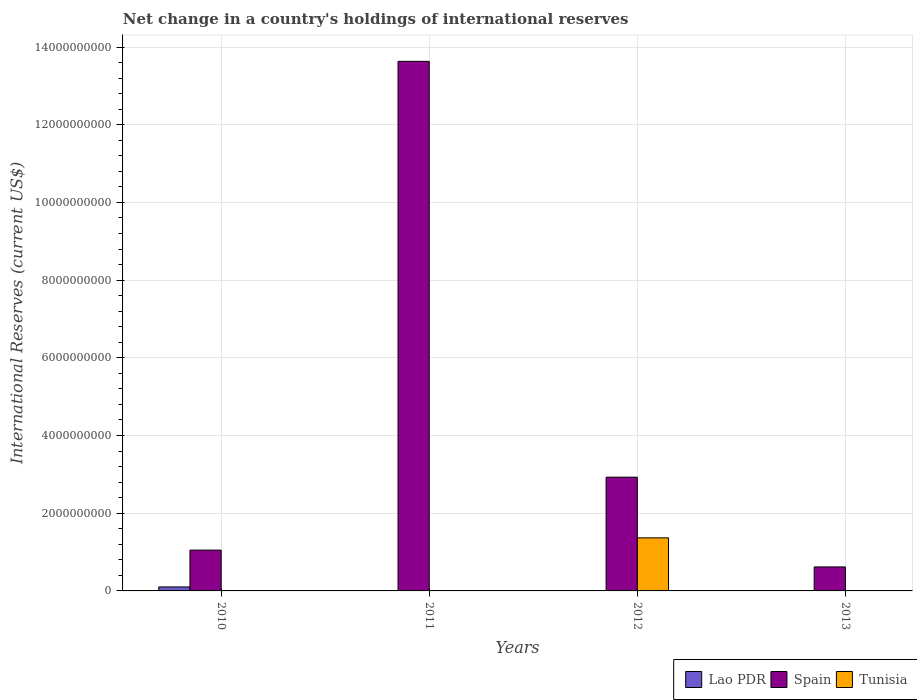How many different coloured bars are there?
Offer a terse response. 3. Are the number of bars per tick equal to the number of legend labels?
Your answer should be very brief. No. What is the label of the 3rd group of bars from the left?
Ensure brevity in your answer.  2012. What is the international reserves in Spain in 2012?
Your answer should be very brief. 2.93e+09. Across all years, what is the maximum international reserves in Lao PDR?
Offer a very short reply. 1.03e+08. Across all years, what is the minimum international reserves in Spain?
Provide a short and direct response. 6.17e+08. In which year was the international reserves in Spain maximum?
Make the answer very short. 2011. What is the total international reserves in Tunisia in the graph?
Your response must be concise. 1.37e+09. What is the difference between the international reserves in Spain in 2010 and that in 2013?
Ensure brevity in your answer.  4.33e+08. What is the difference between the international reserves in Tunisia in 2011 and the international reserves in Spain in 2013?
Give a very brief answer. -6.17e+08. What is the average international reserves in Tunisia per year?
Your answer should be very brief. 3.42e+08. In the year 2010, what is the difference between the international reserves in Spain and international reserves in Lao PDR?
Your answer should be compact. 9.48e+08. What is the ratio of the international reserves in Spain in 2010 to that in 2012?
Give a very brief answer. 0.36. What is the difference between the highest and the second highest international reserves in Spain?
Ensure brevity in your answer.  1.07e+1. What is the difference between the highest and the lowest international reserves in Tunisia?
Provide a short and direct response. 1.37e+09. In how many years, is the international reserves in Lao PDR greater than the average international reserves in Lao PDR taken over all years?
Give a very brief answer. 1. How many bars are there?
Give a very brief answer. 6. Are all the bars in the graph horizontal?
Offer a very short reply. No. How many years are there in the graph?
Keep it short and to the point. 4. What is the difference between two consecutive major ticks on the Y-axis?
Offer a terse response. 2.00e+09. Does the graph contain any zero values?
Your answer should be very brief. Yes. Does the graph contain grids?
Offer a terse response. Yes. Where does the legend appear in the graph?
Make the answer very short. Bottom right. How many legend labels are there?
Your answer should be very brief. 3. How are the legend labels stacked?
Provide a succinct answer. Horizontal. What is the title of the graph?
Offer a very short reply. Net change in a country's holdings of international reserves. What is the label or title of the Y-axis?
Make the answer very short. International Reserves (current US$). What is the International Reserves (current US$) of Lao PDR in 2010?
Ensure brevity in your answer.  1.03e+08. What is the International Reserves (current US$) of Spain in 2010?
Offer a very short reply. 1.05e+09. What is the International Reserves (current US$) of Tunisia in 2010?
Offer a very short reply. 0. What is the International Reserves (current US$) in Lao PDR in 2011?
Your answer should be compact. 0. What is the International Reserves (current US$) in Spain in 2011?
Give a very brief answer. 1.36e+1. What is the International Reserves (current US$) in Spain in 2012?
Offer a very short reply. 2.93e+09. What is the International Reserves (current US$) of Tunisia in 2012?
Your response must be concise. 1.37e+09. What is the International Reserves (current US$) in Spain in 2013?
Offer a terse response. 6.17e+08. Across all years, what is the maximum International Reserves (current US$) in Lao PDR?
Give a very brief answer. 1.03e+08. Across all years, what is the maximum International Reserves (current US$) in Spain?
Make the answer very short. 1.36e+1. Across all years, what is the maximum International Reserves (current US$) in Tunisia?
Keep it short and to the point. 1.37e+09. Across all years, what is the minimum International Reserves (current US$) of Lao PDR?
Provide a succinct answer. 0. Across all years, what is the minimum International Reserves (current US$) in Spain?
Make the answer very short. 6.17e+08. Across all years, what is the minimum International Reserves (current US$) in Tunisia?
Give a very brief answer. 0. What is the total International Reserves (current US$) in Lao PDR in the graph?
Offer a very short reply. 1.03e+08. What is the total International Reserves (current US$) of Spain in the graph?
Ensure brevity in your answer.  1.82e+1. What is the total International Reserves (current US$) of Tunisia in the graph?
Provide a short and direct response. 1.37e+09. What is the difference between the International Reserves (current US$) in Spain in 2010 and that in 2011?
Your response must be concise. -1.26e+1. What is the difference between the International Reserves (current US$) of Spain in 2010 and that in 2012?
Give a very brief answer. -1.88e+09. What is the difference between the International Reserves (current US$) in Spain in 2010 and that in 2013?
Ensure brevity in your answer.  4.33e+08. What is the difference between the International Reserves (current US$) of Spain in 2011 and that in 2012?
Your answer should be compact. 1.07e+1. What is the difference between the International Reserves (current US$) of Spain in 2011 and that in 2013?
Make the answer very short. 1.30e+1. What is the difference between the International Reserves (current US$) in Spain in 2012 and that in 2013?
Offer a terse response. 2.31e+09. What is the difference between the International Reserves (current US$) in Lao PDR in 2010 and the International Reserves (current US$) in Spain in 2011?
Your response must be concise. -1.35e+1. What is the difference between the International Reserves (current US$) in Lao PDR in 2010 and the International Reserves (current US$) in Spain in 2012?
Your answer should be compact. -2.83e+09. What is the difference between the International Reserves (current US$) of Lao PDR in 2010 and the International Reserves (current US$) of Tunisia in 2012?
Give a very brief answer. -1.26e+09. What is the difference between the International Reserves (current US$) of Spain in 2010 and the International Reserves (current US$) of Tunisia in 2012?
Your response must be concise. -3.16e+08. What is the difference between the International Reserves (current US$) in Lao PDR in 2010 and the International Reserves (current US$) in Spain in 2013?
Your response must be concise. -5.15e+08. What is the difference between the International Reserves (current US$) of Spain in 2011 and the International Reserves (current US$) of Tunisia in 2012?
Your answer should be very brief. 1.23e+1. What is the average International Reserves (current US$) in Lao PDR per year?
Make the answer very short. 2.56e+07. What is the average International Reserves (current US$) of Spain per year?
Provide a short and direct response. 4.56e+09. What is the average International Reserves (current US$) in Tunisia per year?
Give a very brief answer. 3.42e+08. In the year 2010, what is the difference between the International Reserves (current US$) in Lao PDR and International Reserves (current US$) in Spain?
Offer a very short reply. -9.48e+08. In the year 2012, what is the difference between the International Reserves (current US$) in Spain and International Reserves (current US$) in Tunisia?
Keep it short and to the point. 1.56e+09. What is the ratio of the International Reserves (current US$) in Spain in 2010 to that in 2011?
Provide a short and direct response. 0.08. What is the ratio of the International Reserves (current US$) of Spain in 2010 to that in 2012?
Offer a terse response. 0.36. What is the ratio of the International Reserves (current US$) in Spain in 2010 to that in 2013?
Your answer should be compact. 1.7. What is the ratio of the International Reserves (current US$) of Spain in 2011 to that in 2012?
Provide a short and direct response. 4.66. What is the ratio of the International Reserves (current US$) of Spain in 2011 to that in 2013?
Offer a very short reply. 22.08. What is the ratio of the International Reserves (current US$) of Spain in 2012 to that in 2013?
Offer a very short reply. 4.74. What is the difference between the highest and the second highest International Reserves (current US$) in Spain?
Make the answer very short. 1.07e+1. What is the difference between the highest and the lowest International Reserves (current US$) in Lao PDR?
Your answer should be very brief. 1.03e+08. What is the difference between the highest and the lowest International Reserves (current US$) of Spain?
Provide a succinct answer. 1.30e+1. What is the difference between the highest and the lowest International Reserves (current US$) in Tunisia?
Keep it short and to the point. 1.37e+09. 